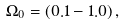Convert formula to latex. <formula><loc_0><loc_0><loc_500><loc_500>\Omega _ { 0 } = ( 0 . 1 - 1 . 0 ) \, ,</formula> 